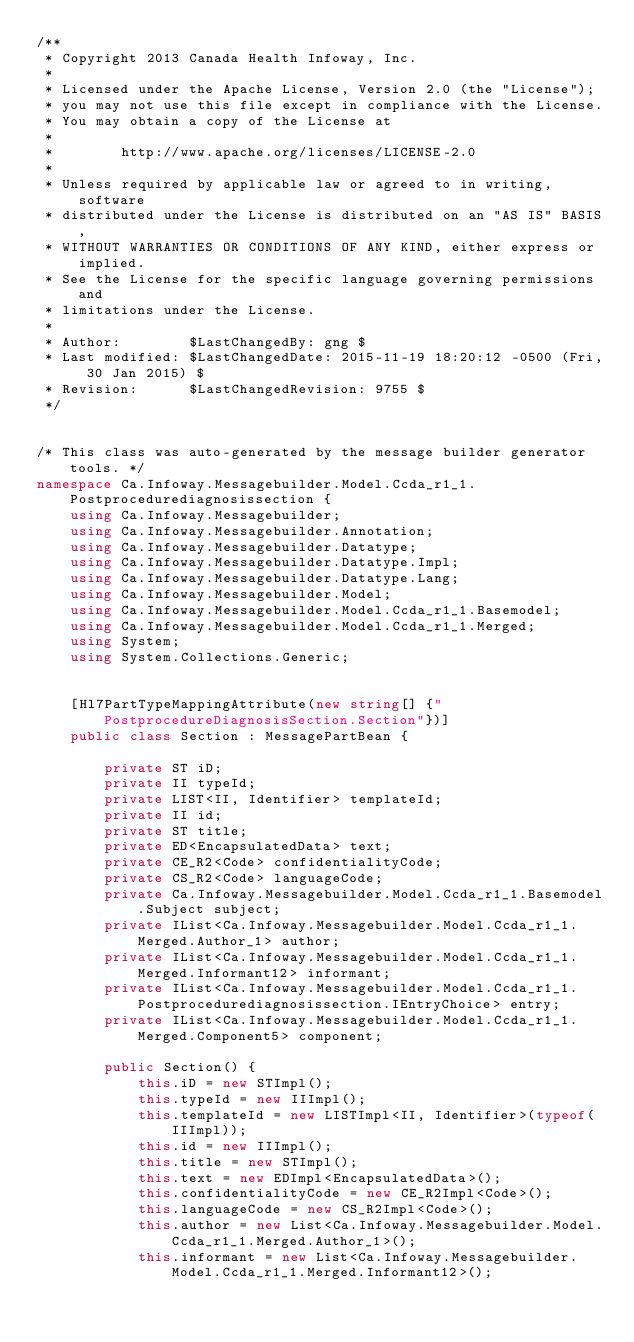Convert code to text. <code><loc_0><loc_0><loc_500><loc_500><_C#_>/**
 * Copyright 2013 Canada Health Infoway, Inc.
 *
 * Licensed under the Apache License, Version 2.0 (the "License");
 * you may not use this file except in compliance with the License.
 * You may obtain a copy of the License at
 *
 *        http://www.apache.org/licenses/LICENSE-2.0
 *
 * Unless required by applicable law or agreed to in writing, software
 * distributed under the License is distributed on an "AS IS" BASIS,
 * WITHOUT WARRANTIES OR CONDITIONS OF ANY KIND, either express or implied.
 * See the License for the specific language governing permissions and
 * limitations under the License.
 *
 * Author:        $LastChangedBy: gng $
 * Last modified: $LastChangedDate: 2015-11-19 18:20:12 -0500 (Fri, 30 Jan 2015) $
 * Revision:      $LastChangedRevision: 9755 $
 */


/* This class was auto-generated by the message builder generator tools. */
namespace Ca.Infoway.Messagebuilder.Model.Ccda_r1_1.Postprocedurediagnosissection {
    using Ca.Infoway.Messagebuilder;
    using Ca.Infoway.Messagebuilder.Annotation;
    using Ca.Infoway.Messagebuilder.Datatype;
    using Ca.Infoway.Messagebuilder.Datatype.Impl;
    using Ca.Infoway.Messagebuilder.Datatype.Lang;
    using Ca.Infoway.Messagebuilder.Model;
    using Ca.Infoway.Messagebuilder.Model.Ccda_r1_1.Basemodel;
    using Ca.Infoway.Messagebuilder.Model.Ccda_r1_1.Merged;
    using System;
    using System.Collections.Generic;


    [Hl7PartTypeMappingAttribute(new string[] {"PostprocedureDiagnosisSection.Section"})]
    public class Section : MessagePartBean {

        private ST iD;
        private II typeId;
        private LIST<II, Identifier> templateId;
        private II id;
        private ST title;
        private ED<EncapsulatedData> text;
        private CE_R2<Code> confidentialityCode;
        private CS_R2<Code> languageCode;
        private Ca.Infoway.Messagebuilder.Model.Ccda_r1_1.Basemodel.Subject subject;
        private IList<Ca.Infoway.Messagebuilder.Model.Ccda_r1_1.Merged.Author_1> author;
        private IList<Ca.Infoway.Messagebuilder.Model.Ccda_r1_1.Merged.Informant12> informant;
        private IList<Ca.Infoway.Messagebuilder.Model.Ccda_r1_1.Postprocedurediagnosissection.IEntryChoice> entry;
        private IList<Ca.Infoway.Messagebuilder.Model.Ccda_r1_1.Merged.Component5> component;

        public Section() {
            this.iD = new STImpl();
            this.typeId = new IIImpl();
            this.templateId = new LISTImpl<II, Identifier>(typeof(IIImpl));
            this.id = new IIImpl();
            this.title = new STImpl();
            this.text = new EDImpl<EncapsulatedData>();
            this.confidentialityCode = new CE_R2Impl<Code>();
            this.languageCode = new CS_R2Impl<Code>();
            this.author = new List<Ca.Infoway.Messagebuilder.Model.Ccda_r1_1.Merged.Author_1>();
            this.informant = new List<Ca.Infoway.Messagebuilder.Model.Ccda_r1_1.Merged.Informant12>();</code> 